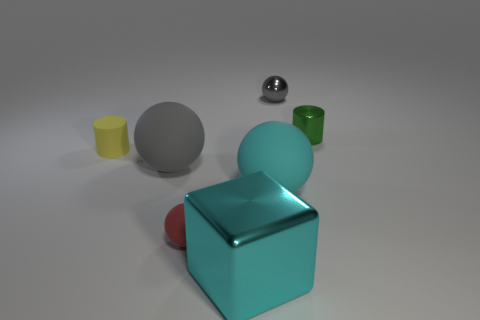Subtract all shiny spheres. How many spheres are left? 3 Add 2 cyan shiny cylinders. How many objects exist? 9 Subtract all red balls. How many balls are left? 3 Subtract 1 balls. How many balls are left? 3 Subtract all cyan cubes. Subtract all big red things. How many objects are left? 6 Add 5 tiny red matte spheres. How many tiny red matte spheres are left? 6 Add 3 small rubber cylinders. How many small rubber cylinders exist? 4 Subtract 0 yellow cubes. How many objects are left? 7 Subtract all blocks. How many objects are left? 6 Subtract all brown cubes. Subtract all brown cylinders. How many cubes are left? 1 